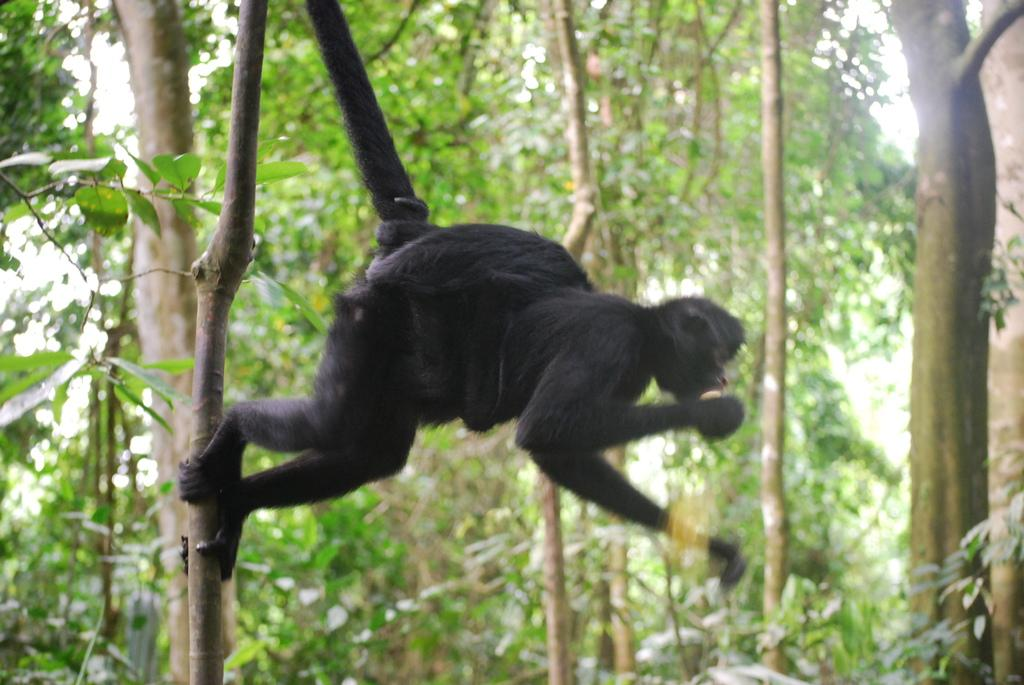What type of living creature is present in the image? There is an animal in the image. What type of natural environment can be seen in the image? There are trees in the image. What part of the natural environment is visible in the image? The sky is visible in the image. What type of appliance can be seen in the image? There is no appliance present in the image. Is there a person visible in the image? The provided facts do not mention the presence of a person, so we cannot definitively answer that question. 